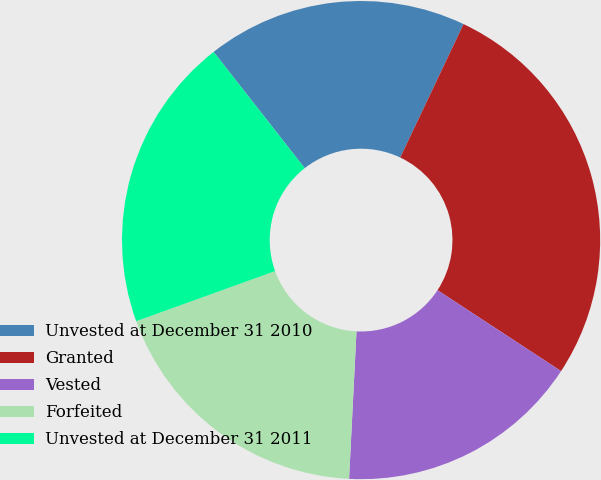Convert chart to OTSL. <chart><loc_0><loc_0><loc_500><loc_500><pie_chart><fcel>Unvested at December 31 2010<fcel>Granted<fcel>Vested<fcel>Forfeited<fcel>Unvested at December 31 2011<nl><fcel>17.63%<fcel>27.18%<fcel>16.57%<fcel>18.69%<fcel>19.93%<nl></chart> 